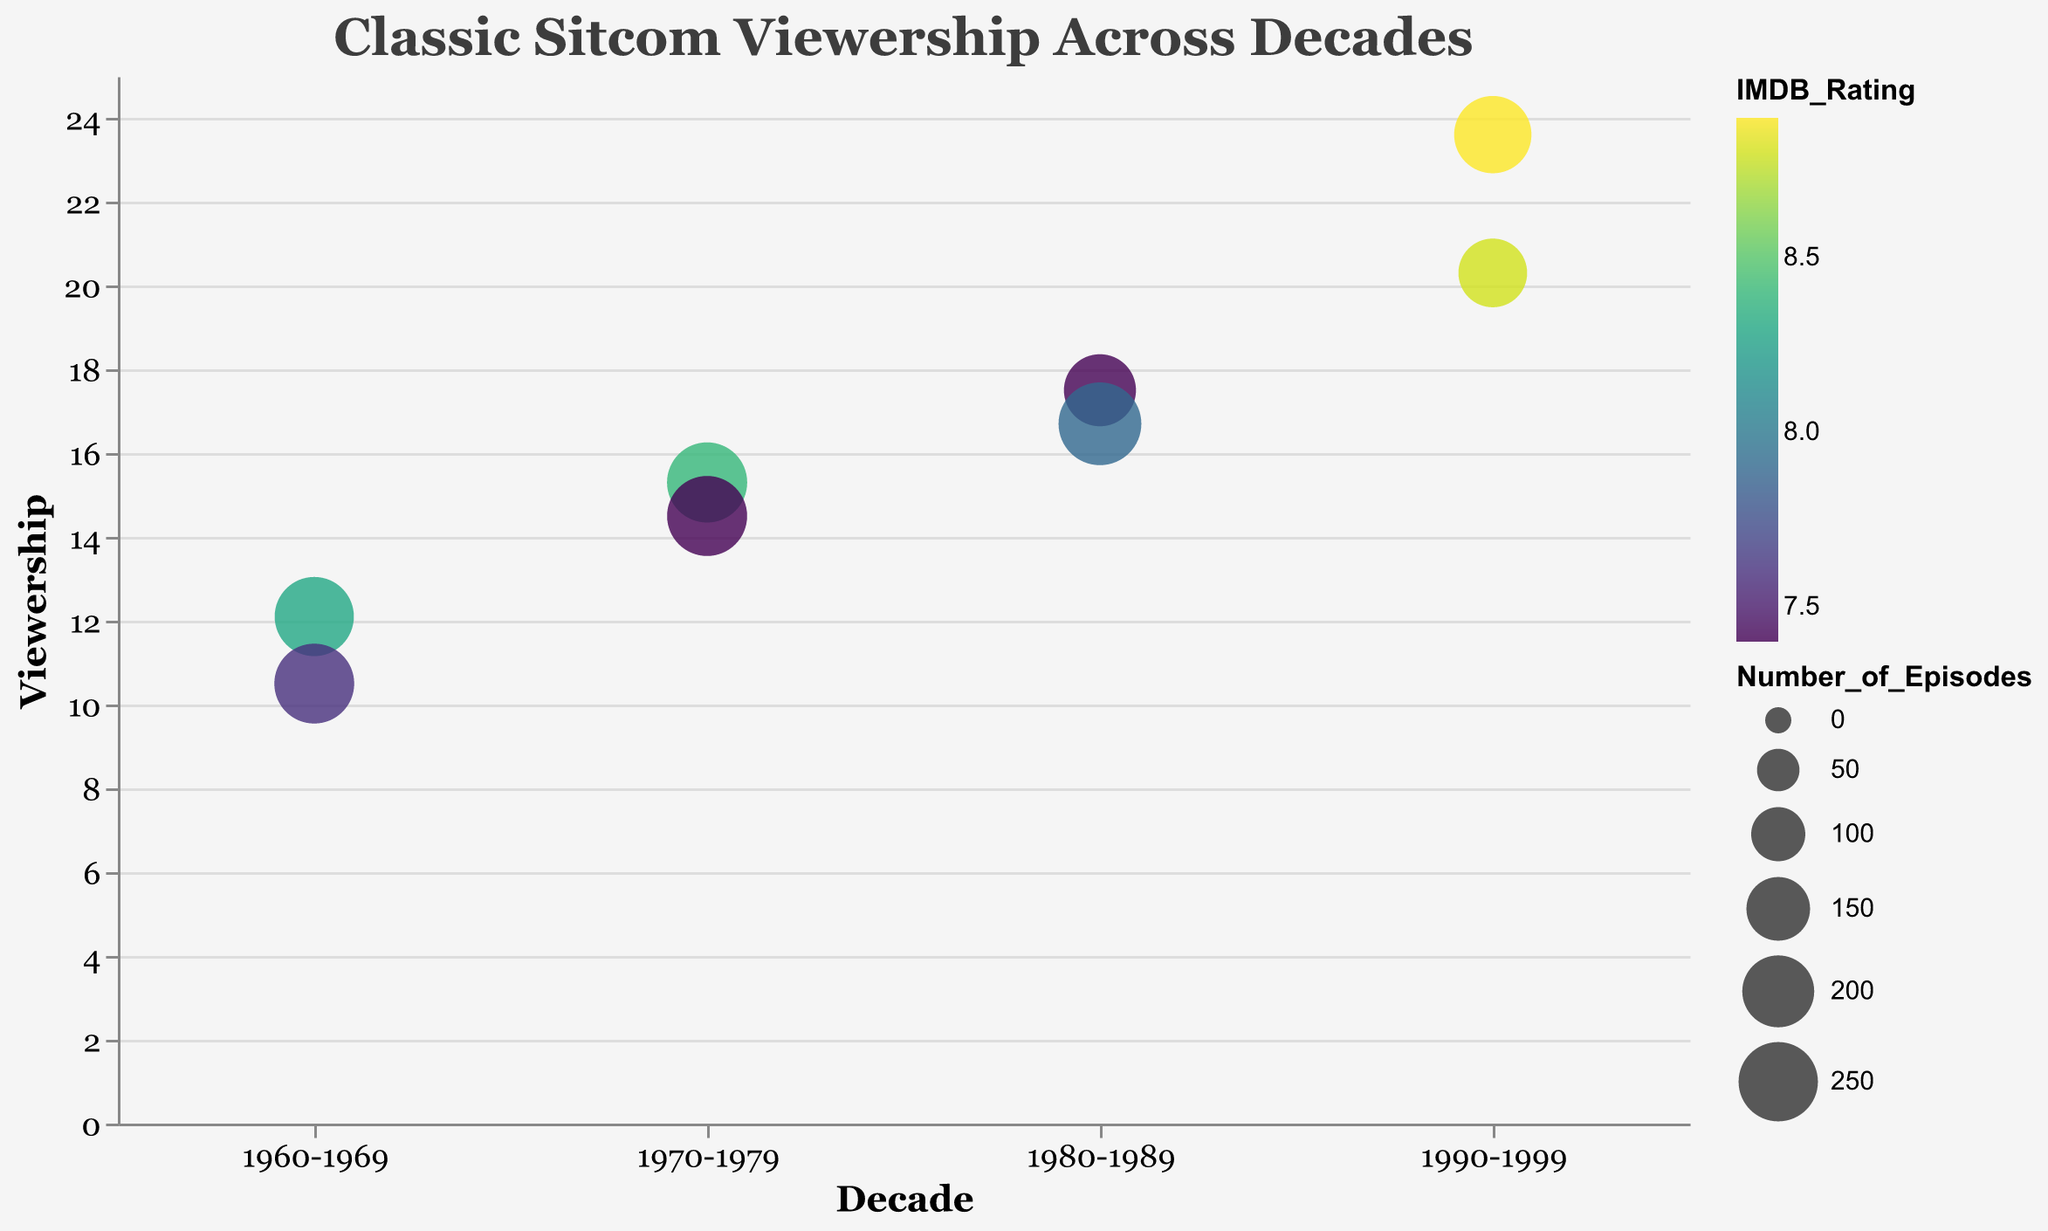What is the title of the chart? The title of the chart is displayed at the top and it reads "Classic Sitcom Viewership Across Decades".
Answer: Classic Sitcom Viewership Across Decades Which sitcom had the highest average viewership? The sitcom with the highest average viewership is represented by the largest y-axis value, which corresponds to "Friends" with a viewership of 23.6.
Answer: Friends In which decade did "Seinfeld" air and what was its IMDB rating? "Seinfeld" aired in the 1990-1999 decade. By hovering over the specific bubble representing "Seinfeld", we can see its tooltip displaying an IMDB rating of 8.8.
Answer: 1990-1999, 8.8 How many episodes did "Cheers" have? By looking at the tooltip for the bubble representing "Cheers" from the 1980-1989 decade, it shows that "Cheers" had 275 episodes.
Answer: 275 Which two sitcoms have the same IMDB rating and what is that rating? Both "The Cosby Show" and "Happy Days" have the same IMDB rating, as indicated by the color of their respective bubbles. By checking their tooltips, their IMDB rating is 7.4.
Answer: The Cosby Show, Happy Days, 7.4 How do the sizes of the bubbles compare for "Friends" and "Happy Days"? The size of the bubbles indicates the number of episodes. "Friends" has 236 episodes, while "Happy Days" has 255 episodes. Therefore, the bubble for "Happy Days" is slightly larger than that for "Friends".
Answer: Happy Days is slightly larger What is the average viewership of sitcoms from the 1980-1989 and 1990-1999 decades? To find the average viewership, sum the viewership of sitcoms in each decade and divide by the number of sitcoms. For 1990-1999: (23.6 + 20.3) / 2 = 21.95; For 1980-1989: (17.5 + 16.7) / 2 = 17.1.
Answer: 21.95, 17.1 Which decade had the sitcom with the lowest viewership and what is the name of that sitcom? The lowest point on the y-axis represents the sitcom with the lowest viewership. "Bewitched" in the 1960-1969 decade has the lowest viewership of 10.5.
Answer: 1960-1969, Bewitched Which decade has the highest number of episodes for a single sitcom and which sitcom is that? To find the highest number of episodes, we look for the largest bubble. From the 1980-1989 decade, "Cheers" has the highest number of episodes with 275 episodes.
Answer: 1980-1989, Cheers 